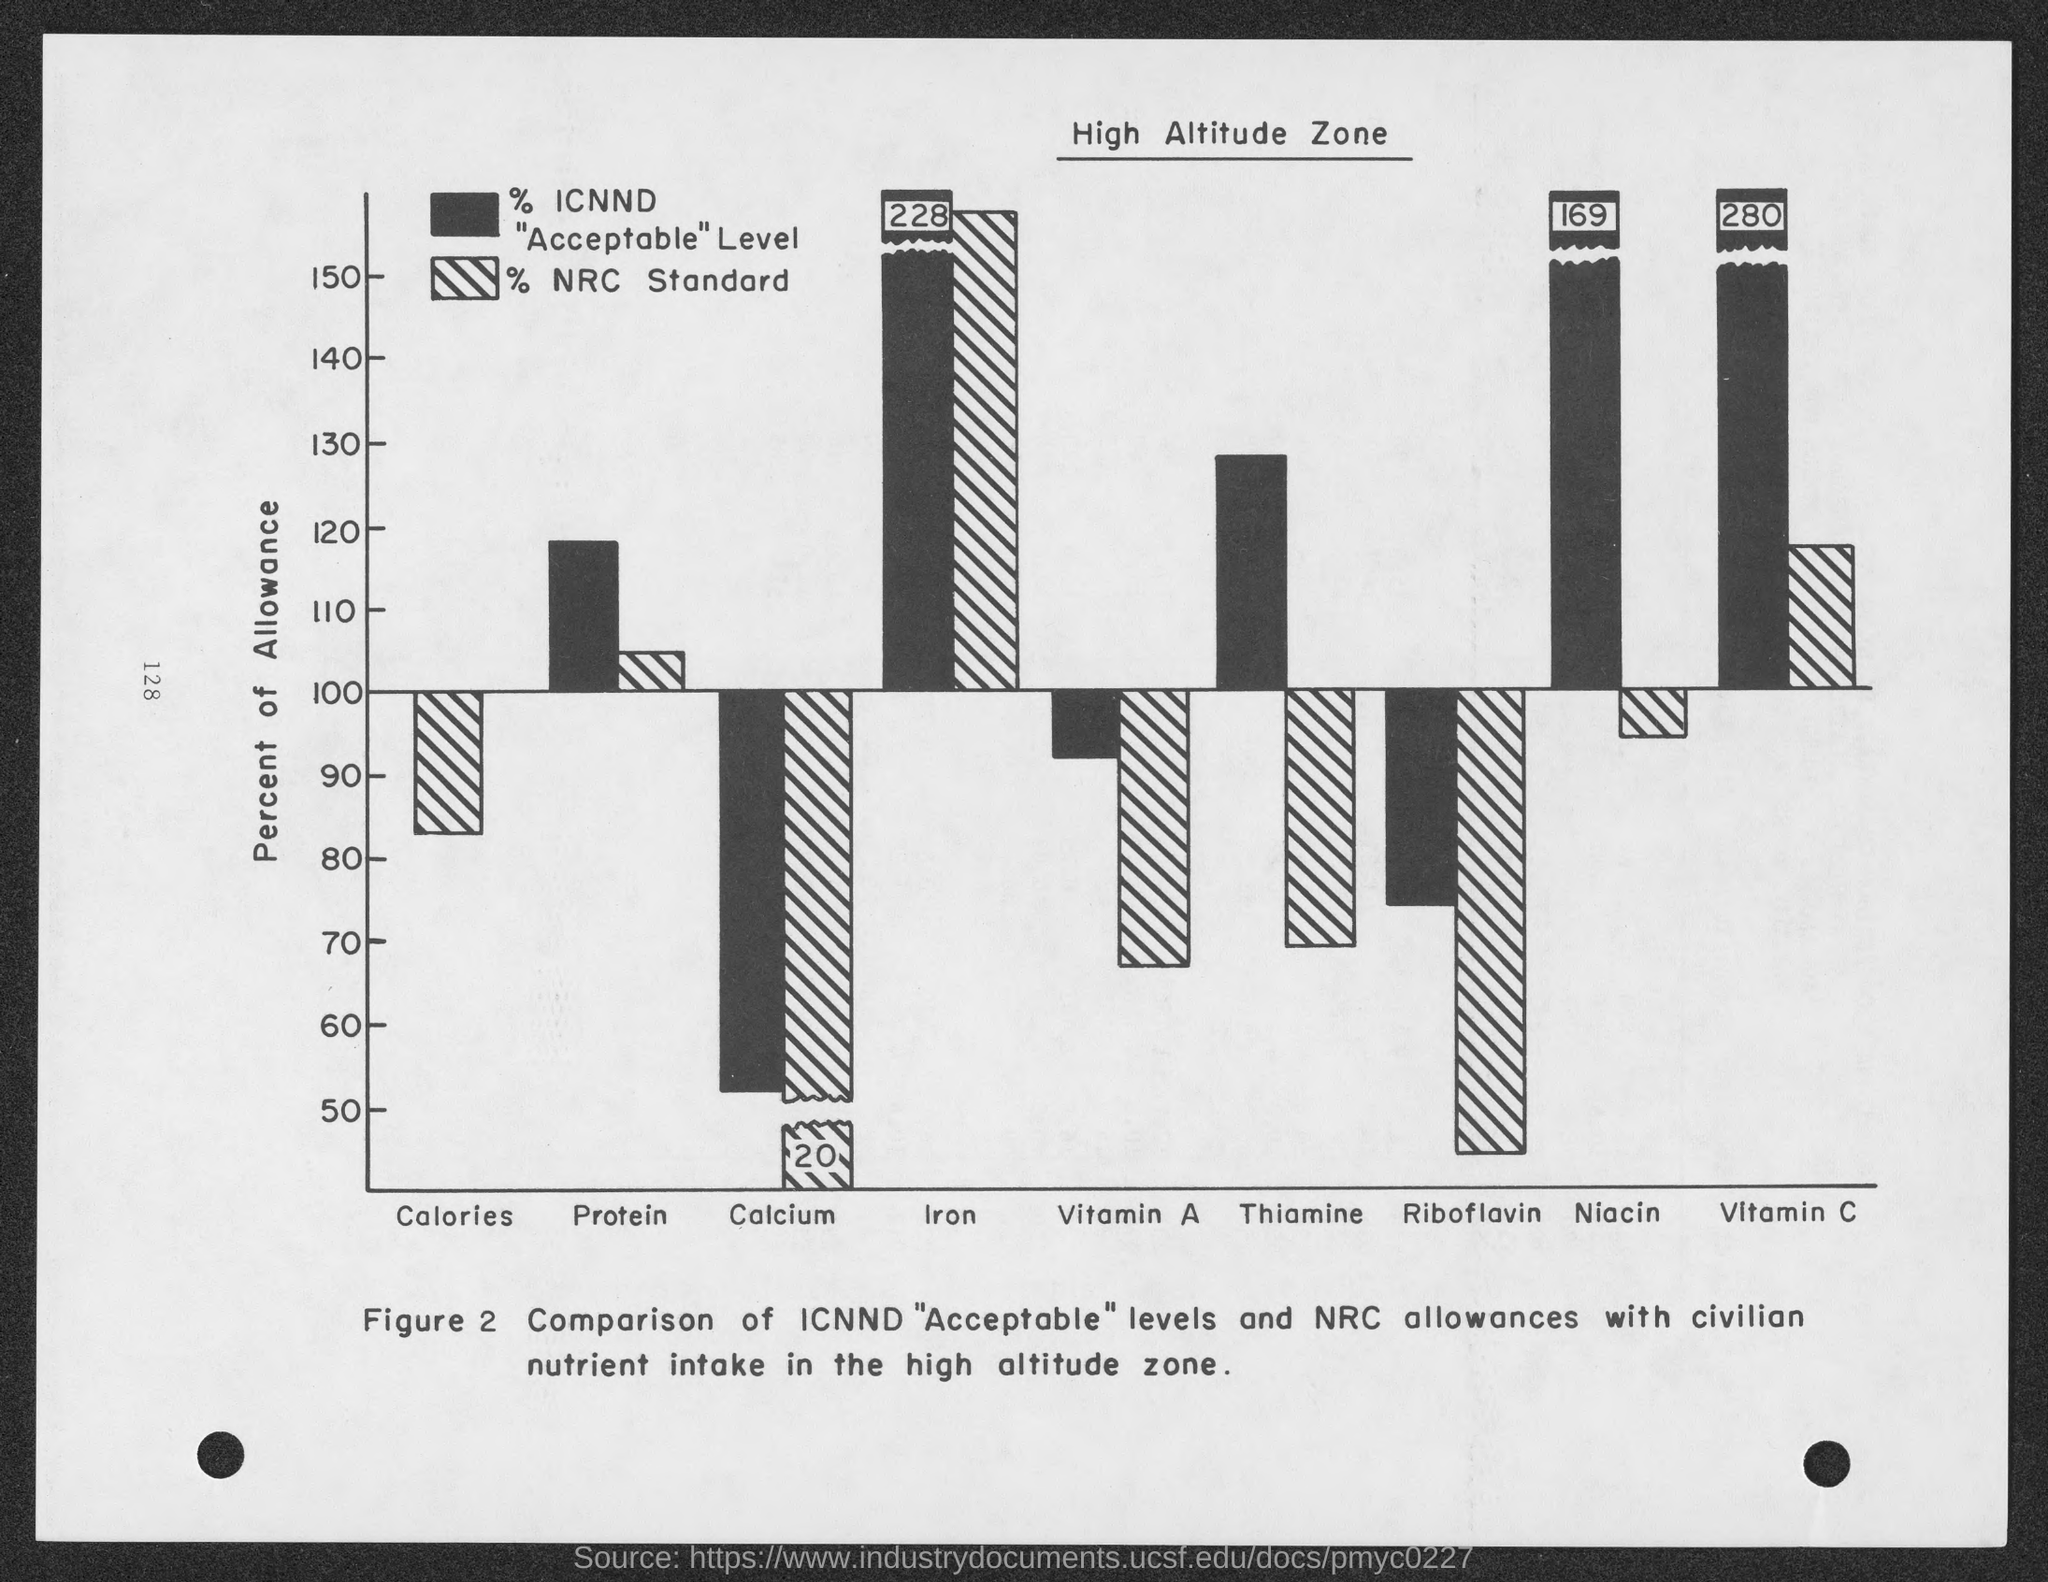What is the Y axis of the bar chart ?
Provide a short and direct response. Percent of Allowance. What is the figure caption?
Make the answer very short. Comparison of ICNND "Acceptable" levels and NRC allowances with civilian nutrient intake in the high altitude zone. 